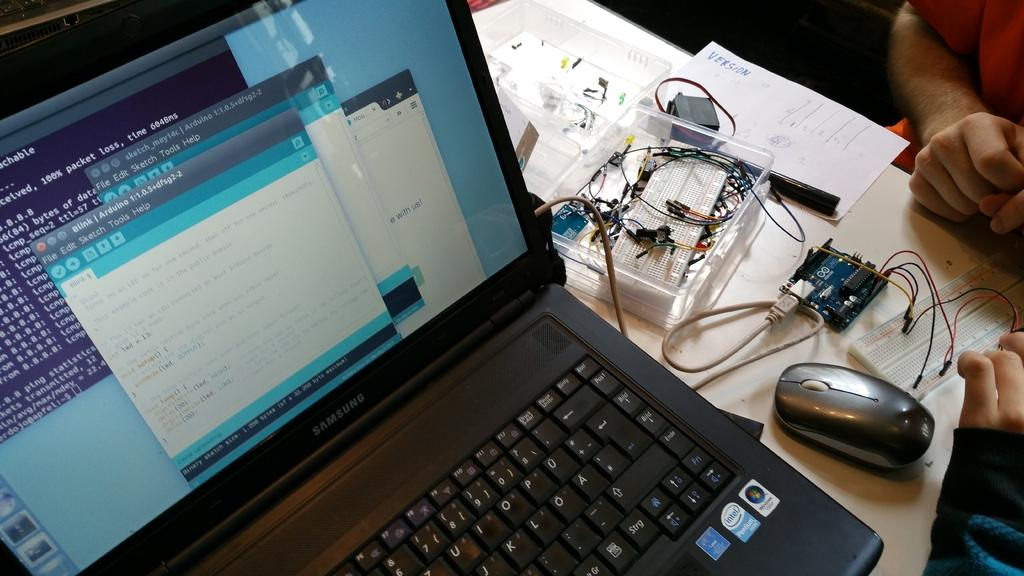<image>
Offer a succinct explanation of the picture presented. A samsung laptop displaying different forms and code sitting on a table. 